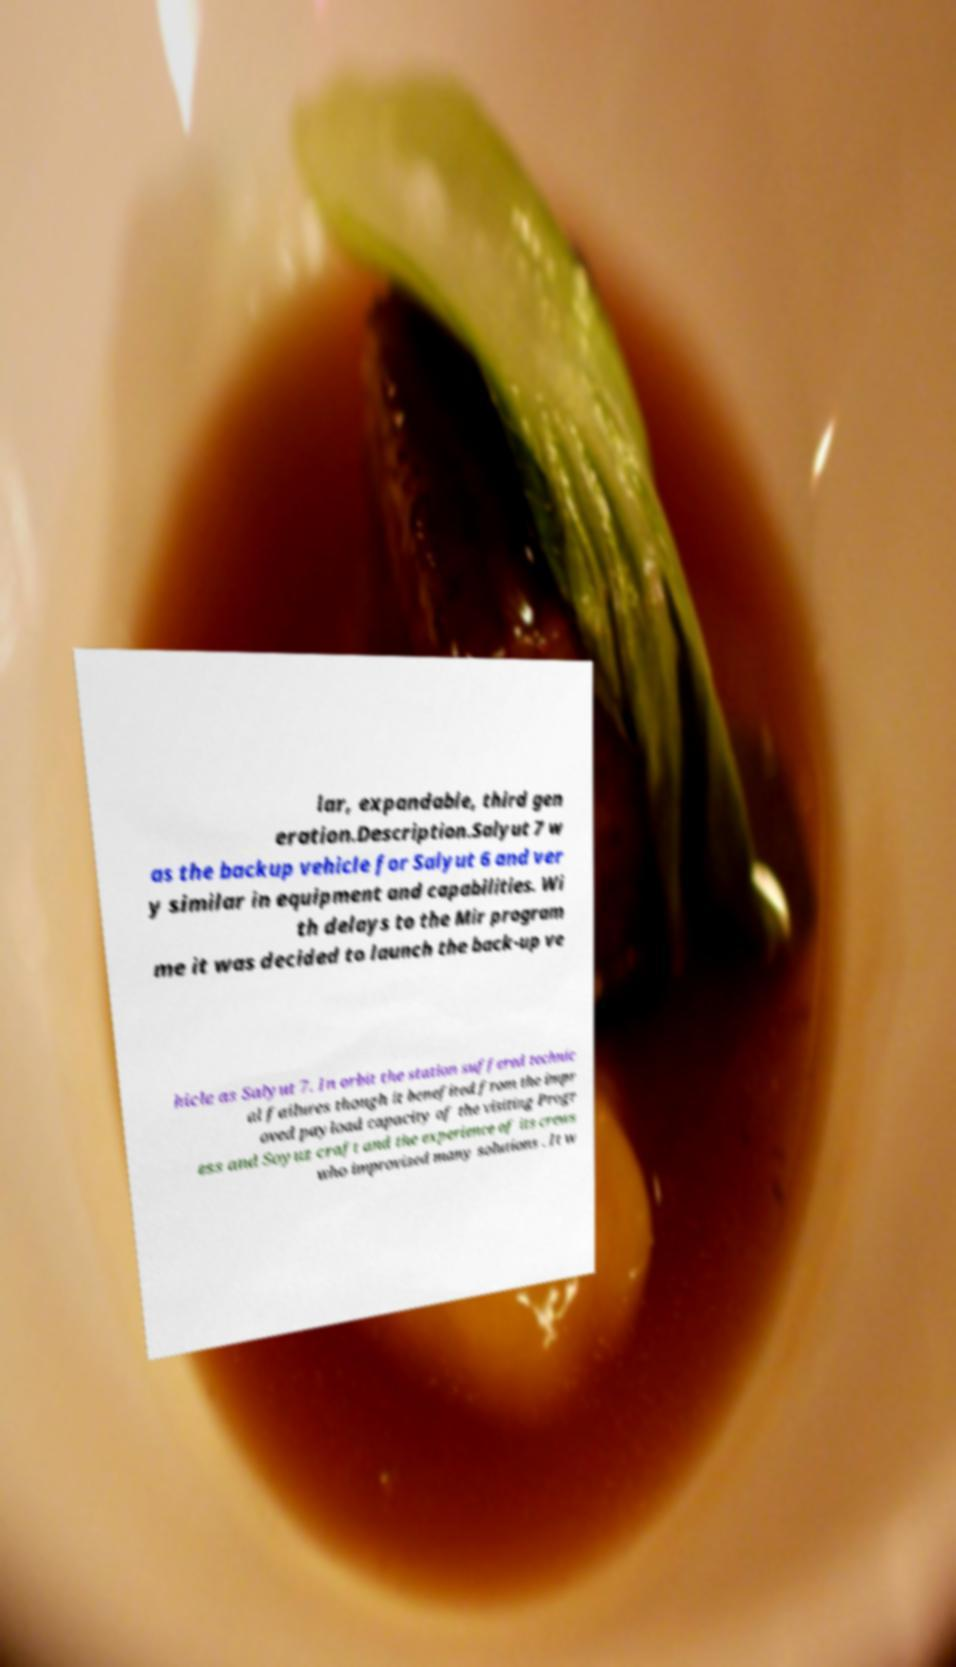Can you accurately transcribe the text from the provided image for me? lar, expandable, third gen eration.Description.Salyut 7 w as the backup vehicle for Salyut 6 and ver y similar in equipment and capabilities. Wi th delays to the Mir program me it was decided to launch the back-up ve hicle as Salyut 7. In orbit the station suffered technic al failures though it benefited from the impr oved payload capacity of the visiting Progr ess and Soyuz craft and the experience of its crews who improvised many solutions . It w 